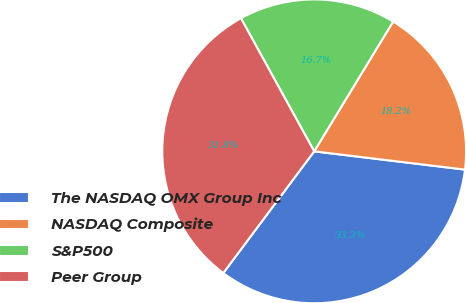<chart> <loc_0><loc_0><loc_500><loc_500><pie_chart><fcel>The NASDAQ OMX Group Inc<fcel>NASDAQ Composite<fcel>S&P500<fcel>Peer Group<nl><fcel>33.29%<fcel>18.22%<fcel>16.71%<fcel>31.78%<nl></chart> 